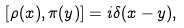<formula> <loc_0><loc_0><loc_500><loc_500>[ \rho ( x ) , \pi ( y ) ] = i \delta ( x - y ) ,</formula> 